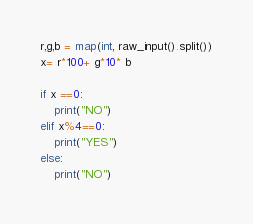<code> <loc_0><loc_0><loc_500><loc_500><_Python_>
r,g,b = map(int, raw_input().split())
x= r*100+ g*10* b

if x ==0:
	print("NO")
elif x%4==0:
	print("YES")
else:
	print("NO")</code> 